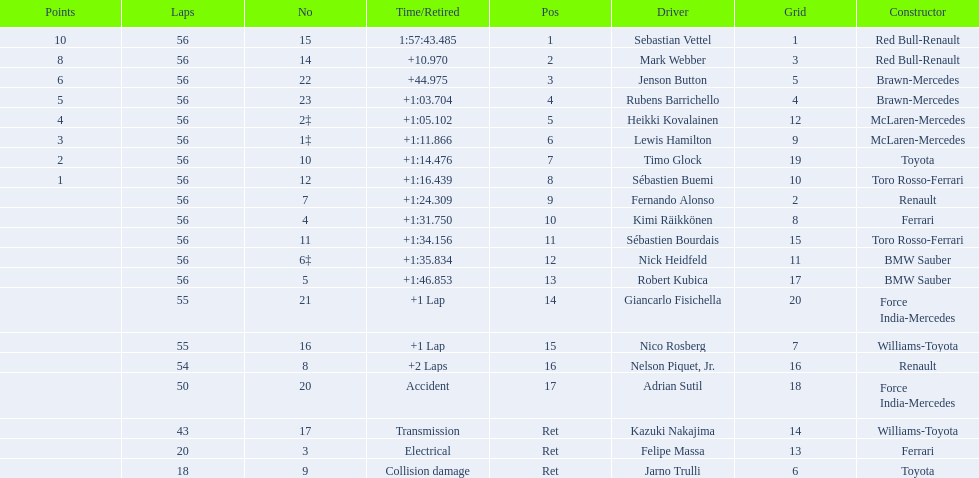Who are all the drivers? Sebastian Vettel, Mark Webber, Jenson Button, Rubens Barrichello, Heikki Kovalainen, Lewis Hamilton, Timo Glock, Sébastien Buemi, Fernando Alonso, Kimi Räikkönen, Sébastien Bourdais, Nick Heidfeld, Robert Kubica, Giancarlo Fisichella, Nico Rosberg, Nelson Piquet, Jr., Adrian Sutil, Kazuki Nakajima, Felipe Massa, Jarno Trulli. What were their finishing times? 1:57:43.485, +10.970, +44.975, +1:03.704, +1:05.102, +1:11.866, +1:14.476, +1:16.439, +1:24.309, +1:31.750, +1:34.156, +1:35.834, +1:46.853, +1 Lap, +1 Lap, +2 Laps, Accident, Transmission, Electrical, Collision damage. Would you be able to parse every entry in this table? {'header': ['Points', 'Laps', 'No', 'Time/Retired', 'Pos', 'Driver', 'Grid', 'Constructor'], 'rows': [['10', '56', '15', '1:57:43.485', '1', 'Sebastian Vettel', '1', 'Red Bull-Renault'], ['8', '56', '14', '+10.970', '2', 'Mark Webber', '3', 'Red Bull-Renault'], ['6', '56', '22', '+44.975', '3', 'Jenson Button', '5', 'Brawn-Mercedes'], ['5', '56', '23', '+1:03.704', '4', 'Rubens Barrichello', '4', 'Brawn-Mercedes'], ['4', '56', '2‡', '+1:05.102', '5', 'Heikki Kovalainen', '12', 'McLaren-Mercedes'], ['3', '56', '1‡', '+1:11.866', '6', 'Lewis Hamilton', '9', 'McLaren-Mercedes'], ['2', '56', '10', '+1:14.476', '7', 'Timo Glock', '19', 'Toyota'], ['1', '56', '12', '+1:16.439', '8', 'Sébastien Buemi', '10', 'Toro Rosso-Ferrari'], ['', '56', '7', '+1:24.309', '9', 'Fernando Alonso', '2', 'Renault'], ['', '56', '4', '+1:31.750', '10', 'Kimi Räikkönen', '8', 'Ferrari'], ['', '56', '11', '+1:34.156', '11', 'Sébastien Bourdais', '15', 'Toro Rosso-Ferrari'], ['', '56', '6‡', '+1:35.834', '12', 'Nick Heidfeld', '11', 'BMW Sauber'], ['', '56', '5', '+1:46.853', '13', 'Robert Kubica', '17', 'BMW Sauber'], ['', '55', '21', '+1 Lap', '14', 'Giancarlo Fisichella', '20', 'Force India-Mercedes'], ['', '55', '16', '+1 Lap', '15', 'Nico Rosberg', '7', 'Williams-Toyota'], ['', '54', '8', '+2 Laps', '16', 'Nelson Piquet, Jr.', '16', 'Renault'], ['', '50', '20', 'Accident', '17', 'Adrian Sutil', '18', 'Force India-Mercedes'], ['', '43', '17', 'Transmission', 'Ret', 'Kazuki Nakajima', '14', 'Williams-Toyota'], ['', '20', '3', 'Electrical', 'Ret', 'Felipe Massa', '13', 'Ferrari'], ['', '18', '9', 'Collision damage', 'Ret', 'Jarno Trulli', '6', 'Toyota']]} Who finished last? Robert Kubica. 